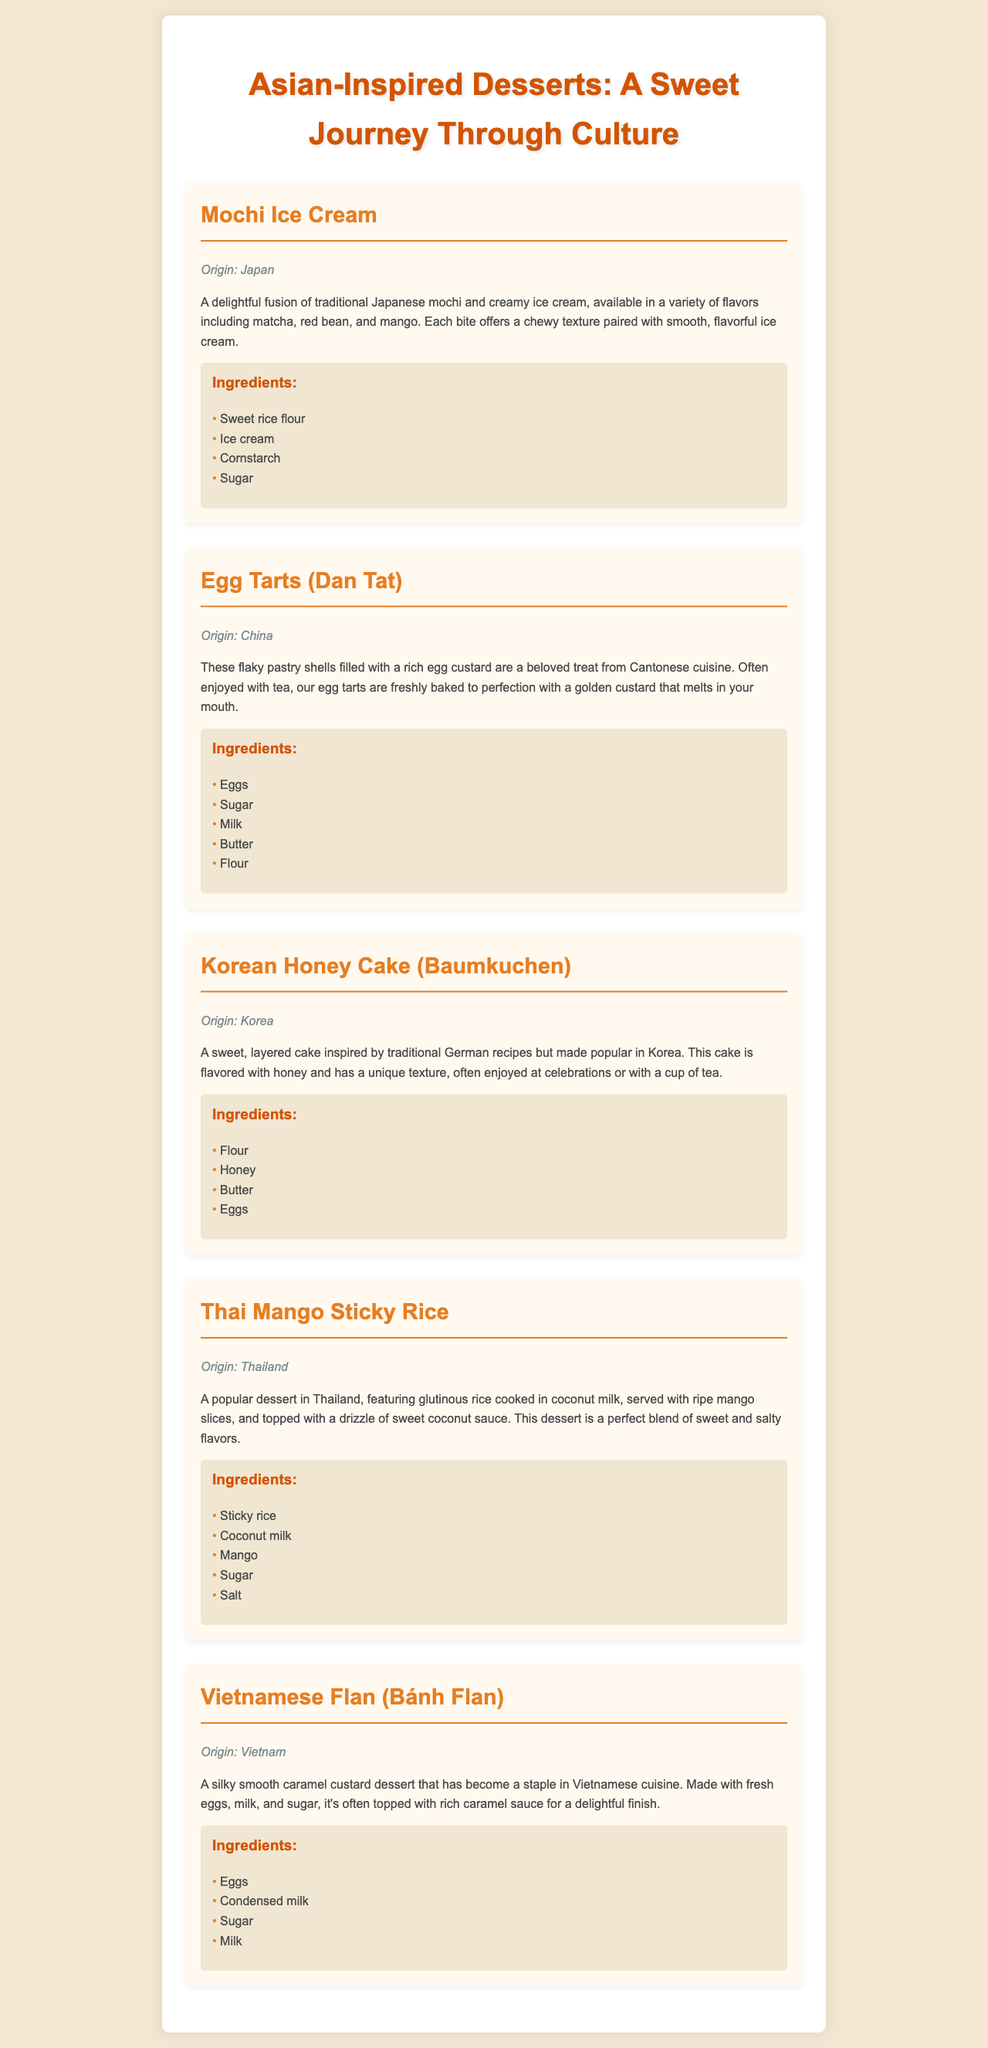What is the origin of Mochi Ice Cream? The origin of Mochi Ice Cream is specified in the document as Japan.
Answer: Japan Which dessert is known for its flaky pastry shells? The document mentions that Egg Tarts (Dan Tat) are known for their flaky pastry shells.
Answer: Egg Tarts (Dan Tat) How many ingredients are listed for Thai Mango Sticky Rice? The document provides a list of five ingredients for Thai Mango Sticky Rice.
Answer: Five What unique flavor is highlighted in Korean Honey Cake? The document states that Korean Honey Cake is flavored with honey.
Answer: Honey What is a common serving suggestion for Egg Tarts? The document indicates that Egg Tarts are often enjoyed with tea.
Answer: With tea What type of dessert is Vietnamese Flan? The document describes Vietnamese Flan as a caramel custard dessert.
Answer: Caramel custard Which dessert features glutinous rice cooked in coconut milk? Thai Mango Sticky Rice is highlighted in the document for featuring glutinous rice cooked in coconut milk.
Answer: Thai Mango Sticky Rice What is the last ingredient listed for Mochi Ice Cream? According to the document, the last ingredient listed for Mochi Ice Cream is sugar.
Answer: Sugar 